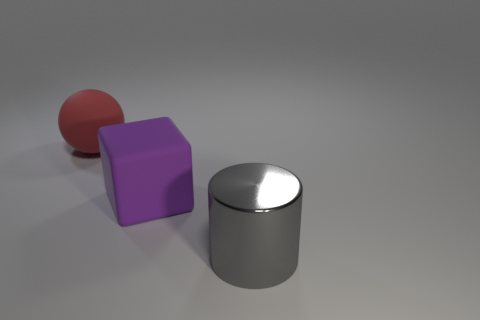What material is the purple object?
Your answer should be compact. Rubber. What is the shape of the gray shiny thing that is the same size as the block?
Offer a very short reply. Cylinder. Is there a big rubber ball that has the same color as the rubber block?
Offer a terse response. No. There is a big cube; is its color the same as the big thing that is in front of the purple matte object?
Provide a succinct answer. No. What is the color of the matte object that is on the right side of the object that is to the left of the purple object?
Give a very brief answer. Purple. There is a object that is behind the large rubber thing in front of the large sphere; are there any things that are left of it?
Give a very brief answer. No. There is a cube that is the same material as the red sphere; what is its color?
Your response must be concise. Purple. What number of gray things have the same material as the big purple object?
Provide a succinct answer. 0. Are the red ball and the thing right of the big block made of the same material?
Your answer should be very brief. No. How many things are things that are on the left side of the metal cylinder or large gray cylinders?
Give a very brief answer. 3. 